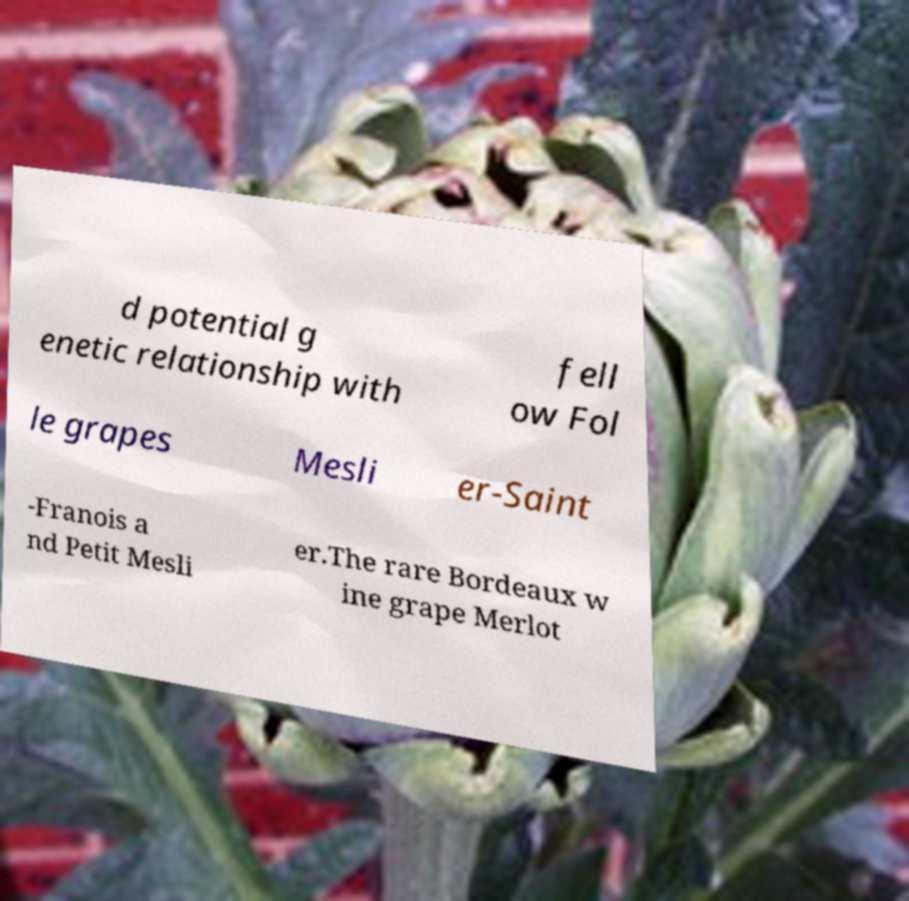Could you extract and type out the text from this image? d potential g enetic relationship with fell ow Fol le grapes Mesli er-Saint -Franois a nd Petit Mesli er.The rare Bordeaux w ine grape Merlot 